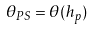<formula> <loc_0><loc_0><loc_500><loc_500>\theta _ { P S } = \theta ( h _ { p } )</formula> 